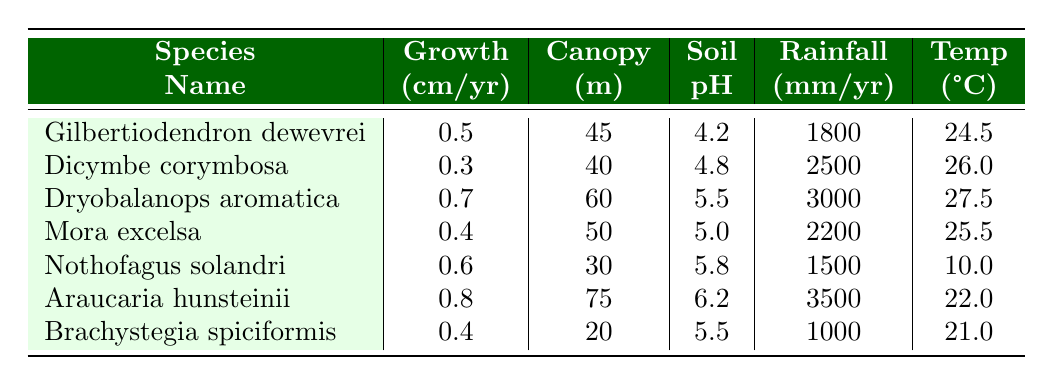What is the annual growth rate of Dryobalanops aromatica? The table lists the annual growth rate of Dryobalanops aromatica as 0.7 cm/yr.
Answer: 0.7 cm/yr Which species has the highest average canopy height? By comparing the average canopy heights in the table, Araucaria hunsteinii has the highest canopy height at 75 m.
Answer: 75 m Is the soil pH of Mora excelsa greater than the soil pH of Nothofagus solandri? The soil pH for Mora excelsa is 5.0, and for Nothofagus solandri, it is 5.8. Since 5.0 is not greater than 5.8, the answer is no.
Answer: No What is the average annual growth rate of all listed species? To find the average growth rate, sum the individual growth rates: (0.5 + 0.3 + 0.7 + 0.4 + 0.6 + 0.8 + 0.4) = 3.7. There are 7 species, so the average is 3.7 / 7 = 0.529 cm/yr.
Answer: 0.529 cm/yr How much more annual rainfall does Araucaria hunsteinii receive compared to Brachystegia spiciformis? The annual rainfall for Araucaria hunsteinii is 3500 mm, and for Brachystegia spiciformis, it is 1000 mm. The difference is 3500 mm - 1000 mm = 2500 mm.
Answer: 2500 mm Which species has the lowest average temperature? Checking the table, Nothofagus solandri has the lowest average temperature of 10.0 °C.
Answer: 10.0 °C Is the growth rate of Dicymbe corymbosa less than that of Mora excelsa? The growth rate for Dicymbe corymbosa is 0.3 cm/yr and for Mora excelsa is 0.4 cm/yr. Since 0.3 is less than 0.4, the answer is yes.
Answer: Yes What is the difference in soil pH between the species with the highest and lowest soil pH? Highest pH is for Araucaria hunsteinii at 6.2, and the lowest is for Gilbertiodendron dewevrei at 4.2. The difference is 6.2 - 4.2 = 2.0.
Answer: 2.0 Which species is found in the Congo Basin? The table indicates that Gilbertiodendron dewevrei is found in the Congo Basin.
Answer: Gilbertiodendron dewevrei What is the average canopy height of all the species listed? To find the average, we sum: (45 + 40 + 60 + 50 + 30 + 75 + 20) = 320 m. There are 7 species, so 320 / 7 ≈ 45.71 m.
Answer: 45.71 m 